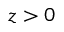<formula> <loc_0><loc_0><loc_500><loc_500>z > 0</formula> 